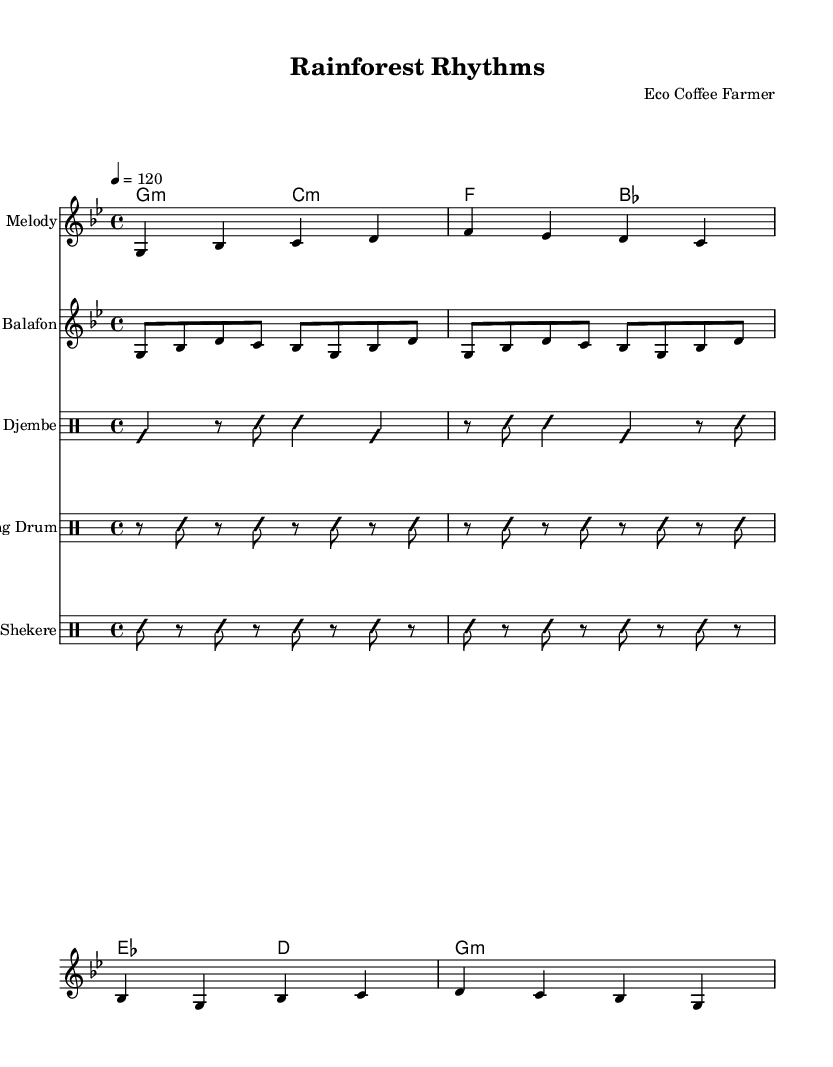What is the key signature of this music? The key signature is indicated on the staff at the beginning of the score. The presence of two flats indicates that the music is in G minor.
Answer: G minor What is the time signature of this music? The time signature is indicated by the notation at the beginning of the score, which shows 4 beats in a measure, so it is 4/4.
Answer: 4/4 What is the tempo marking in this score? The tempo marking is specified as "4 = 120," which indicates that there are 120 beats per minute.
Answer: 120 How many measures are present in the melody? By counting the measures in the melody staff from start to finish, there are a total of 4 measures.
Answer: 4 Which instruments are featured in this piece? The instruments are listed in the score under the title, which includes Melody, Balafon, Djembe, Talking Drum, and Shekere.
Answer: Melody, Balafon, Djembe, Talking Drum, Shekere What type of rhythmic style is primarily used in this music? The music predominantly features percussion-driven rhythms that are characteristic of West African musical traditions.
Answer: Percussion-driven rhythms 